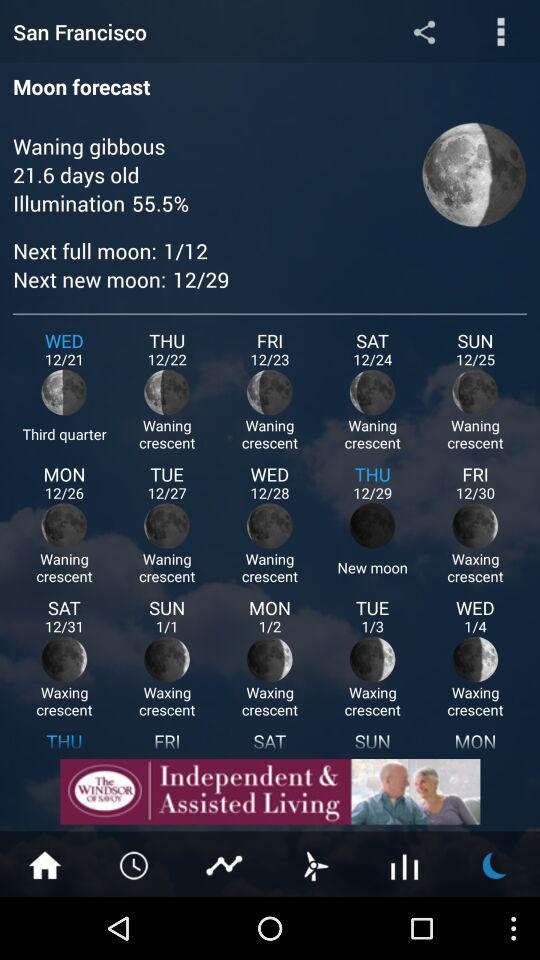How many days are there between the waning crescent moon on 12/24 and the waxing crescent moon on 1/4?
Answer the question using a single word or phrase. 10 